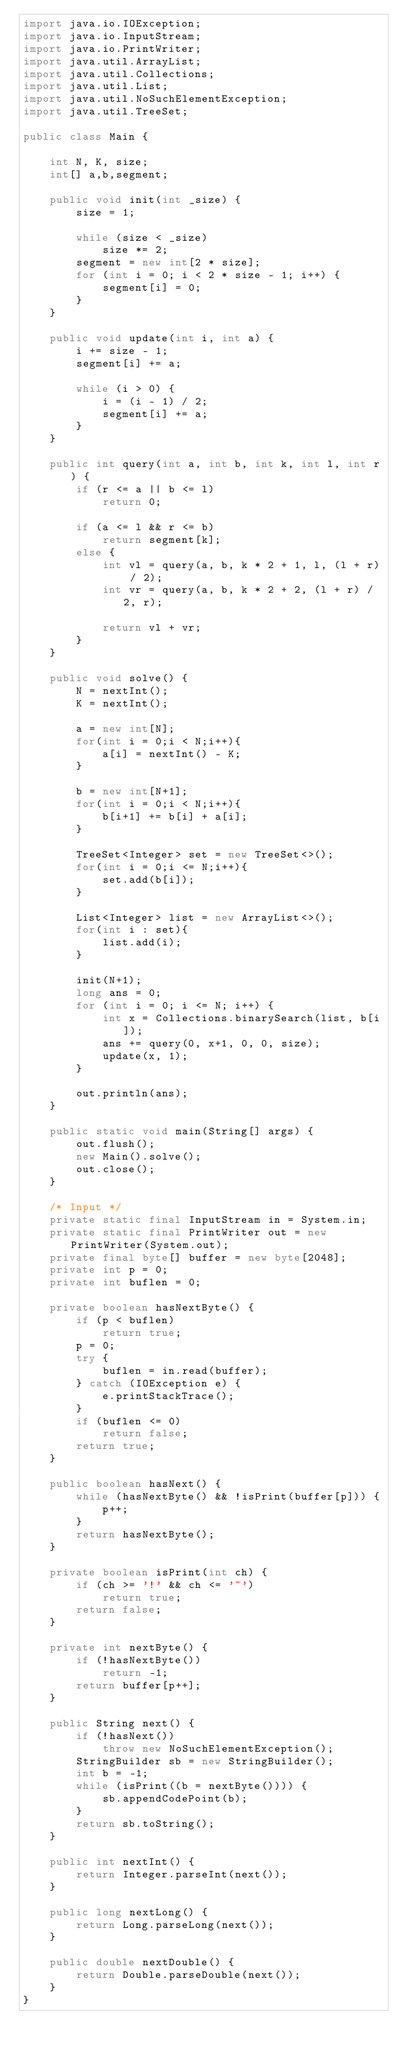<code> <loc_0><loc_0><loc_500><loc_500><_Java_>import java.io.IOException;
import java.io.InputStream;
import java.io.PrintWriter;
import java.util.ArrayList;
import java.util.Collections;
import java.util.List;
import java.util.NoSuchElementException;
import java.util.TreeSet;

public class Main {

	int N, K, size;
	int[] a,b,segment;

	public void init(int _size) {
		size = 1;

		while (size < _size)
			size *= 2;
		segment = new int[2 * size];
		for (int i = 0; i < 2 * size - 1; i++) {
			segment[i] = 0;
		}
	}

	public void update(int i, int a) {
		i += size - 1;
		segment[i] += a;

		while (i > 0) {
			i = (i - 1) / 2;
			segment[i] += a;
		}
	}

	public int query(int a, int b, int k, int l, int r) {
		if (r <= a || b <= l)
			return 0;

		if (a <= l && r <= b)
			return segment[k];
		else {
			int vl = query(a, b, k * 2 + 1, l, (l + r) / 2);
			int vr = query(a, b, k * 2 + 2, (l + r) / 2, r);

			return vl + vr;
		}
	}

	public void solve() {
		N = nextInt();
		K = nextInt();

		a = new int[N];
		for(int i = 0;i < N;i++){
			a[i] = nextInt() - K;
		}

		b = new int[N+1];
		for(int i = 0;i < N;i++){
			b[i+1] += b[i] + a[i];
		}

		TreeSet<Integer> set = new TreeSet<>();
		for(int i = 0;i <= N;i++){
			set.add(b[i]);
		}

		List<Integer> list = new ArrayList<>();
		for(int i : set){
			list.add(i);
		}

		init(N+1);
		long ans = 0;
		for (int i = 0; i <= N; i++) {
			int x = Collections.binarySearch(list, b[i]);
			ans += query(0, x+1, 0, 0, size);
			update(x, 1);
		}

		out.println(ans);
	}

	public static void main(String[] args) {
		out.flush();
		new Main().solve();
		out.close();
	}

	/* Input */
	private static final InputStream in = System.in;
	private static final PrintWriter out = new PrintWriter(System.out);
	private final byte[] buffer = new byte[2048];
	private int p = 0;
	private int buflen = 0;

	private boolean hasNextByte() {
		if (p < buflen)
			return true;
		p = 0;
		try {
			buflen = in.read(buffer);
		} catch (IOException e) {
			e.printStackTrace();
		}
		if (buflen <= 0)
			return false;
		return true;
	}

	public boolean hasNext() {
		while (hasNextByte() && !isPrint(buffer[p])) {
			p++;
		}
		return hasNextByte();
	}

	private boolean isPrint(int ch) {
		if (ch >= '!' && ch <= '~')
			return true;
		return false;
	}

	private int nextByte() {
		if (!hasNextByte())
			return -1;
		return buffer[p++];
	}

	public String next() {
		if (!hasNext())
			throw new NoSuchElementException();
		StringBuilder sb = new StringBuilder();
		int b = -1;
		while (isPrint((b = nextByte()))) {
			sb.appendCodePoint(b);
		}
		return sb.toString();
	}

	public int nextInt() {
		return Integer.parseInt(next());
	}

	public long nextLong() {
		return Long.parseLong(next());
	}

	public double nextDouble() {
		return Double.parseDouble(next());
	}
}</code> 